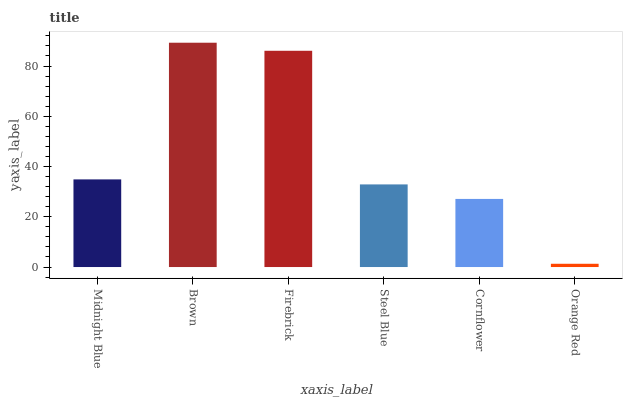Is Orange Red the minimum?
Answer yes or no. Yes. Is Brown the maximum?
Answer yes or no. Yes. Is Firebrick the minimum?
Answer yes or no. No. Is Firebrick the maximum?
Answer yes or no. No. Is Brown greater than Firebrick?
Answer yes or no. Yes. Is Firebrick less than Brown?
Answer yes or no. Yes. Is Firebrick greater than Brown?
Answer yes or no. No. Is Brown less than Firebrick?
Answer yes or no. No. Is Midnight Blue the high median?
Answer yes or no. Yes. Is Steel Blue the low median?
Answer yes or no. Yes. Is Cornflower the high median?
Answer yes or no. No. Is Brown the low median?
Answer yes or no. No. 